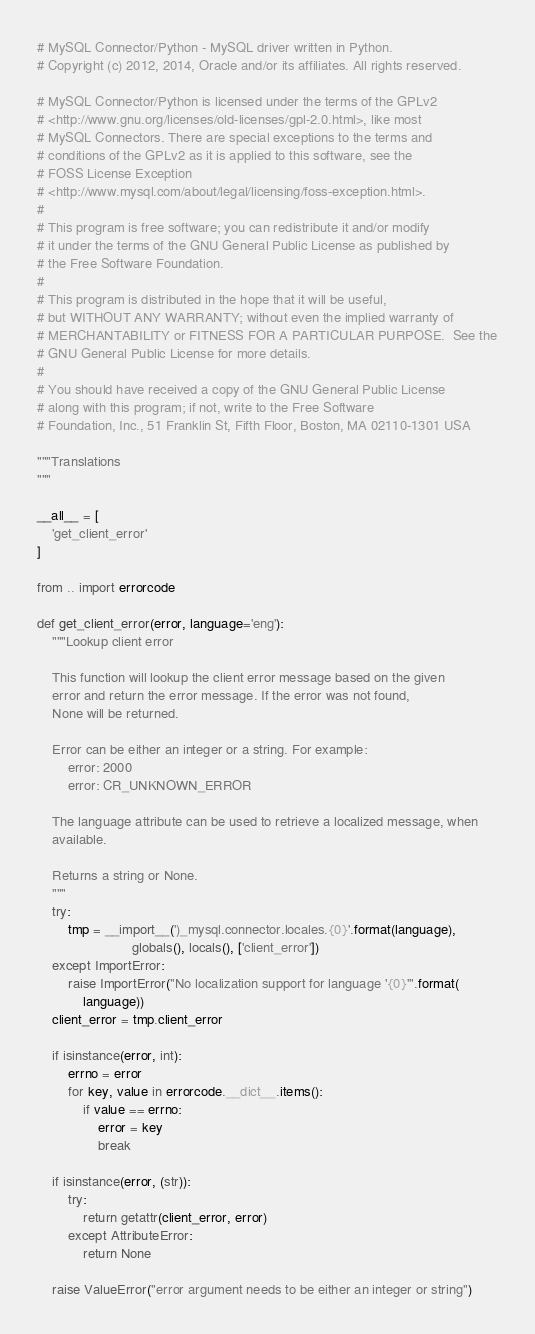Convert code to text. <code><loc_0><loc_0><loc_500><loc_500><_Python_># MySQL Connector/Python - MySQL driver written in Python.
# Copyright (c) 2012, 2014, Oracle and/or its affiliates. All rights reserved.

# MySQL Connector/Python is licensed under the terms of the GPLv2
# <http://www.gnu.org/licenses/old-licenses/gpl-2.0.html>, like most
# MySQL Connectors. There are special exceptions to the terms and
# conditions of the GPLv2 as it is applied to this software, see the
# FOSS License Exception
# <http://www.mysql.com/about/legal/licensing/foss-exception.html>.
#
# This program is free software; you can redistribute it and/or modify
# it under the terms of the GNU General Public License as published by
# the Free Software Foundation.
#
# This program is distributed in the hope that it will be useful,
# but WITHOUT ANY WARRANTY; without even the implied warranty of
# MERCHANTABILITY or FITNESS FOR A PARTICULAR PURPOSE.  See the
# GNU General Public License for more details.
#
# You should have received a copy of the GNU General Public License
# along with this program; if not, write to the Free Software
# Foundation, Inc., 51 Franklin St, Fifth Floor, Boston, MA 02110-1301 USA

"""Translations
"""

__all__ = [
    'get_client_error'
]

from .. import errorcode

def get_client_error(error, language='eng'):
    """Lookup client error

    This function will lookup the client error message based on the given
    error and return the error message. If the error was not found,
    None will be returned.

    Error can be either an integer or a string. For example:
        error: 2000
        error: CR_UNKNOWN_ERROR

    The language attribute can be used to retrieve a localized message, when
    available.

    Returns a string or None.
    """
    try:
        tmp = __import__(')_mysql.connector.locales.{0}'.format(language),
                         globals(), locals(), ['client_error'])
    except ImportError:
        raise ImportError("No localization support for language '{0}'".format(
            language))
    client_error = tmp.client_error

    if isinstance(error, int):
        errno = error
        for key, value in errorcode.__dict__.items():
            if value == errno:
                error = key
                break

    if isinstance(error, (str)):
        try:
            return getattr(client_error, error)
        except AttributeError:
            return None

    raise ValueError("error argument needs to be either an integer or string")

</code> 